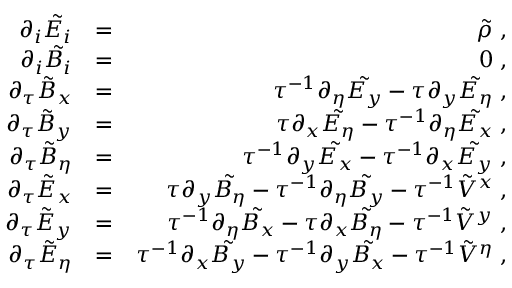Convert formula to latex. <formula><loc_0><loc_0><loc_500><loc_500>\begin{array} { r l r } { \partial _ { i } \tilde { E _ { i } } } & { = } & { \tilde { \rho } \, , } \\ { \partial _ { i } \tilde { B _ { i } } } & { = } & { 0 \, , } \\ { \partial _ { \tau } \tilde { B } _ { x } } & { = } & { \tau ^ { - 1 } \partial _ { \eta } \tilde { E _ { y } } - \tau \partial _ { y } \tilde { E _ { \eta } } \, , } \\ { \partial _ { \tau } \tilde { B } _ { y } } & { = } & { \tau \partial _ { x } \tilde { E _ { \eta } } - \tau ^ { - 1 } \partial _ { \eta } \tilde { E _ { x } } \, , } \\ { \partial _ { \tau } \tilde { B } _ { \eta } } & { = } & { \tau ^ { - 1 } \partial _ { y } \tilde { E _ { x } } - \tau ^ { - 1 } \partial _ { x } \tilde { E _ { y } } \, , } \\ { \partial _ { \tau } \tilde { E } _ { x } } & { = } & { \tau \partial _ { y } \tilde { B _ { \eta } } - \tau ^ { - 1 } \partial _ { \eta } \tilde { B _ { y } } - \tau ^ { - 1 } \tilde { V } ^ { x } \, , } \\ { \partial _ { \tau } \tilde { E } _ { y } } & { = } & { \tau ^ { - 1 } \partial _ { \eta } \tilde { B _ { x } } - \tau \partial _ { x } \tilde { B _ { \eta } } - \tau ^ { - 1 } \tilde { V } ^ { y } \, , } \\ { \partial _ { \tau } \tilde { E } _ { \eta } } & { = } & { \tau ^ { - 1 } \partial _ { x } \tilde { B _ { y } } - \tau ^ { - 1 } \partial _ { y } \tilde { B _ { x } } - \tau ^ { - 1 } \tilde { V } ^ { \eta } \, , } \end{array}</formula> 